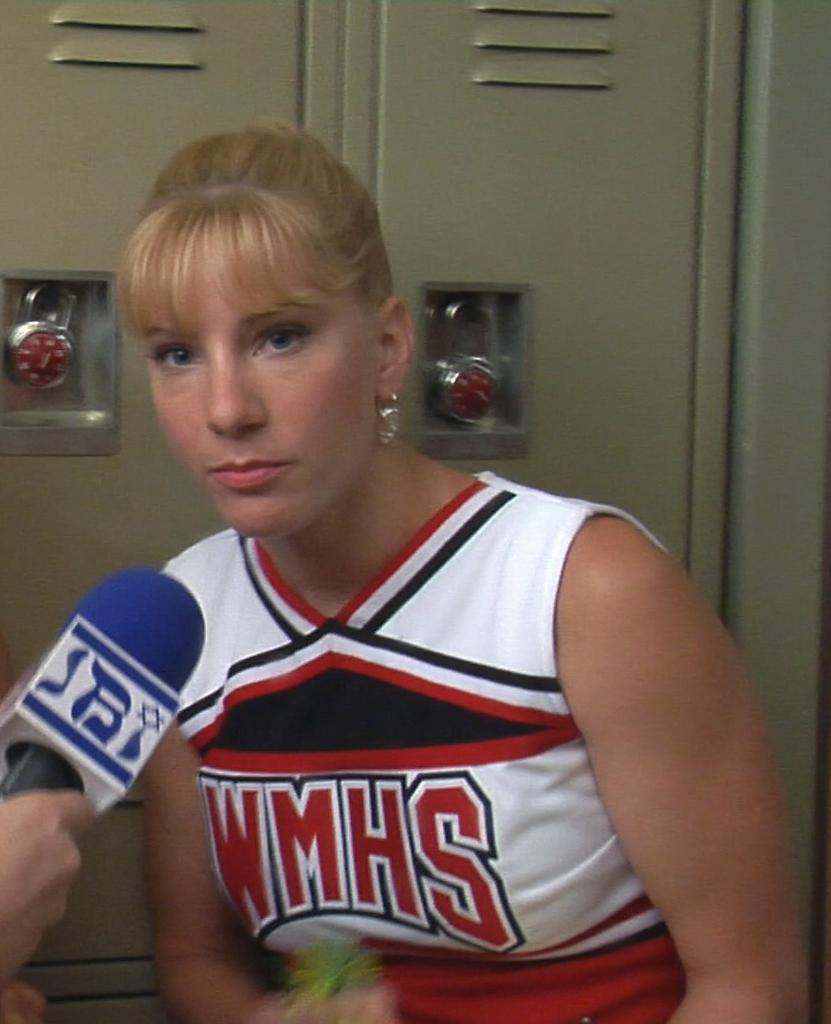<image>
Present a compact description of the photo's key features. A blond cheerleader talks into a microphone with WMHS on her uniform. 